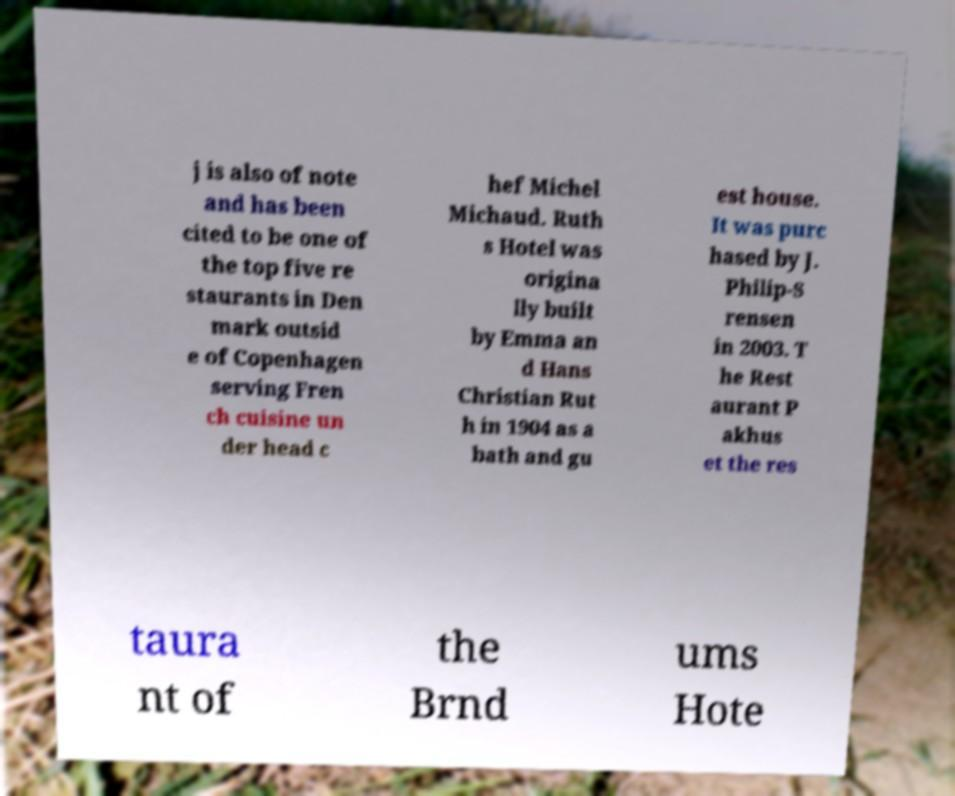There's text embedded in this image that I need extracted. Can you transcribe it verbatim? j is also of note and has been cited to be one of the top five re staurants in Den mark outsid e of Copenhagen serving Fren ch cuisine un der head c hef Michel Michaud. Ruth s Hotel was origina lly built by Emma an d Hans Christian Rut h in 1904 as a bath and gu est house. It was purc hased by J. Philip-S rensen in 2003. T he Rest aurant P akhus et the res taura nt of the Brnd ums Hote 